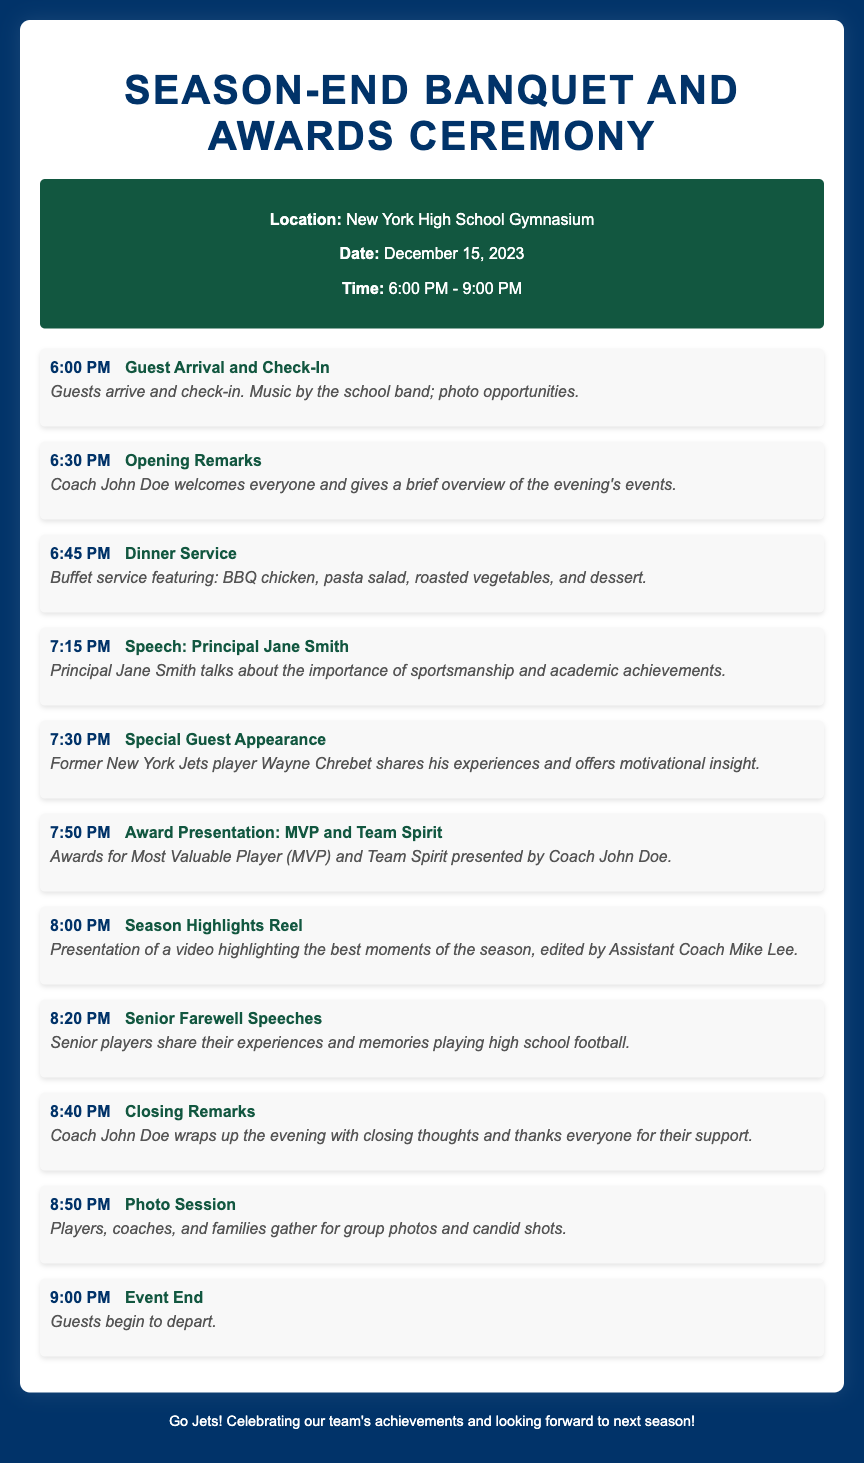What is the location of the event? The document specifies that the event will take place in the New York High School Gymnasium.
Answer: New York High School Gymnasium What time does the event start? The itinerary indicates that guest arrival begins at 6:00 PM.
Answer: 6:00 PM Who will present the MVP award? According to the itinerary, Coach John Doe will present the MVP award.
Answer: Coach John Doe What type of food is served during dinner? The document lists the dinner menu to include BBQ chicken, pasta salad, roasted vegetables, and dessert.
Answer: BBQ chicken, pasta salad, roasted vegetables, and dessert What is included in the Senior Farewell speeches? The itinerary mentions that senior players will share their experiences and memories of playing high school football.
Answer: Experiences and memories playing high school football At what time is the Season Highlights Reel presented? The document states that the Season Highlights Reel presentation is scheduled for 8:00 PM.
Answer: 8:00 PM What is the significance of the special guest appearance? The itinerary notes that former New York Jets player Wayne Chrebet shares his experiences and offers motivational insight.
Answer: Motivational insight How long does the event last? The document indicates that the event goes from 6:00 PM to 9:00 PM, totaling 3 hours.
Answer: 3 hours What activity concludes the evening? The itinerary specifies that a photo session will close the event before guests begin to depart.
Answer: Photo Session 